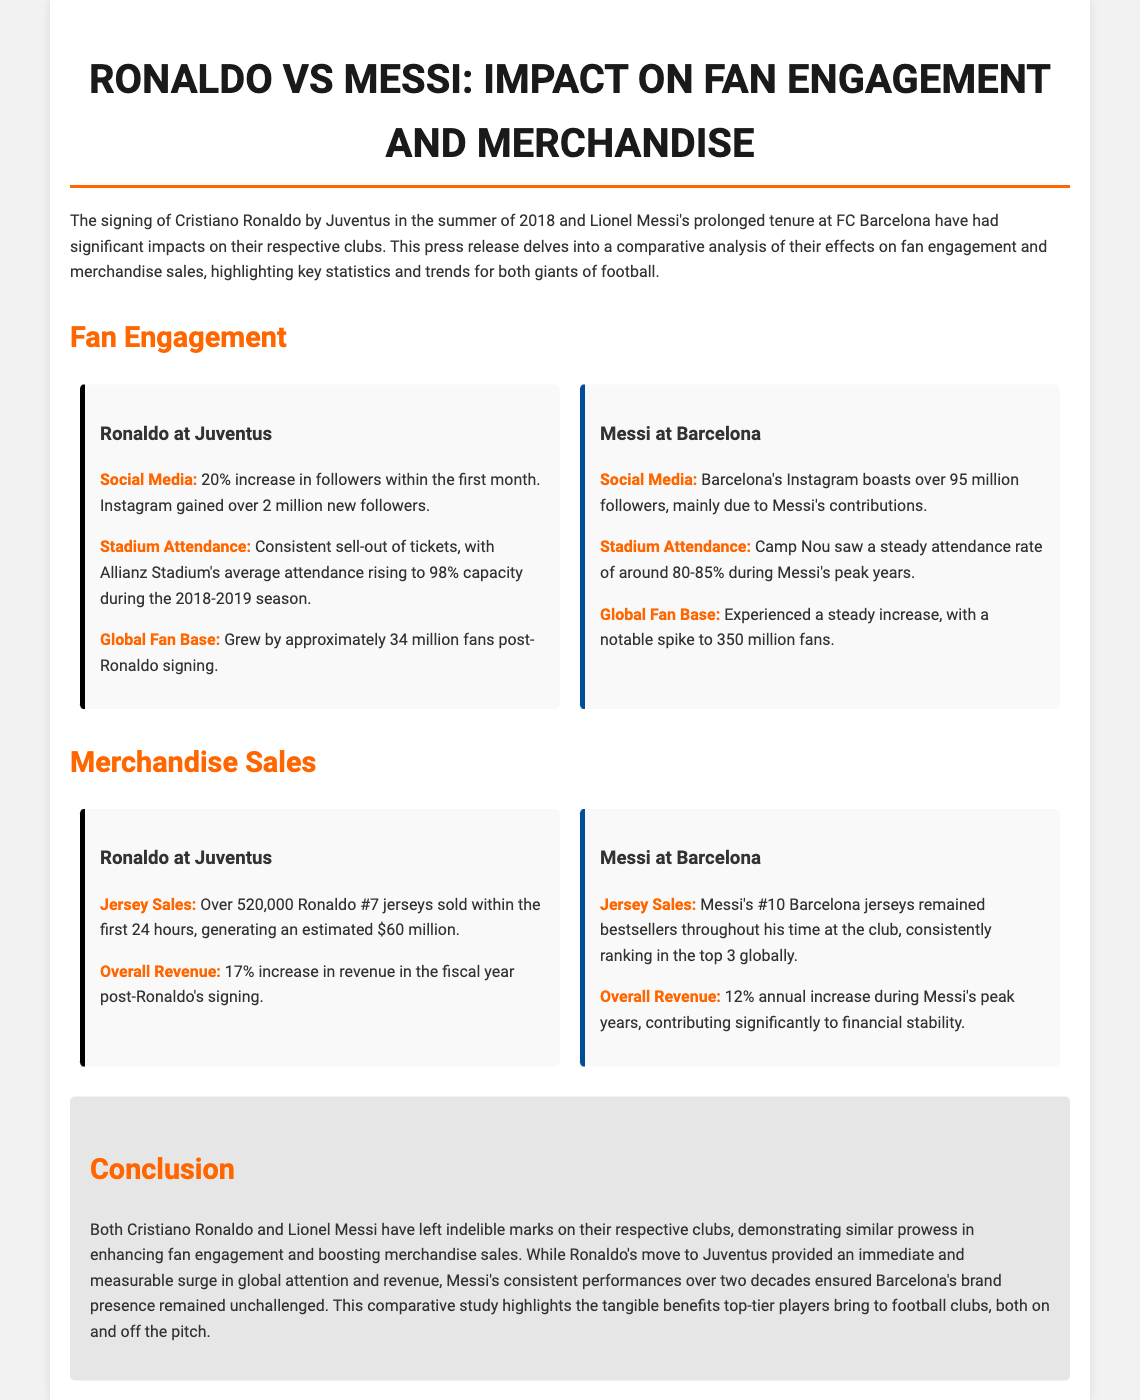what was the percentage increase in social media followers for Ronaldo? The document states there was a 20% increase in followers within the first month after Ronaldo's signing.
Answer: 20% how many new followers did Juventus gain on Instagram after Ronaldo's signing? According to the document, Juventus gained over 2 million new followers on Instagram after Ronaldo's arrival.
Answer: 2 million what was the average attendance at Allianz Stadium during the 2018-2019 season? The average attendance at Allianz Stadium rose to 98% capacity during the 2018-2019 season as stated in the document.
Answer: 98% how many jerseys were sold within the first 24 hours of Ronaldo's signing? The document reports that over 520,000 Ronaldo #7 jerseys were sold within the first 24 hours.
Answer: 520,000 what percentage increase in revenue did Juventus experience after Ronaldo's signing? Juventus experienced a 17% increase in revenue in the fiscal year following Ronaldo’s signing according to the document.
Answer: 17% how many global fans did Juventus gain after signing Ronaldo? The document mentions that Juventus's global fan base grew by approximately 34 million fans after Ronaldo's signing.
Answer: 34 million what was the average attendance at Camp Nou during Messi's peak years? The document indicates that Camp Nou had a steady attendance rate of around 80-85% during Messi's peak years.
Answer: 80-85% how much revenue increase did Barcelona see during Messi's peak years? The document states that Barcelona had a 12% annual increase in revenue during Messi's peak years.
Answer: 12% what significant impact did Ronaldo have on Juventus' merchandise sales? The document highlights that Ronaldo's jerseys generated an estimated $60 million in the first 24 hours of sales.
Answer: $60 million 